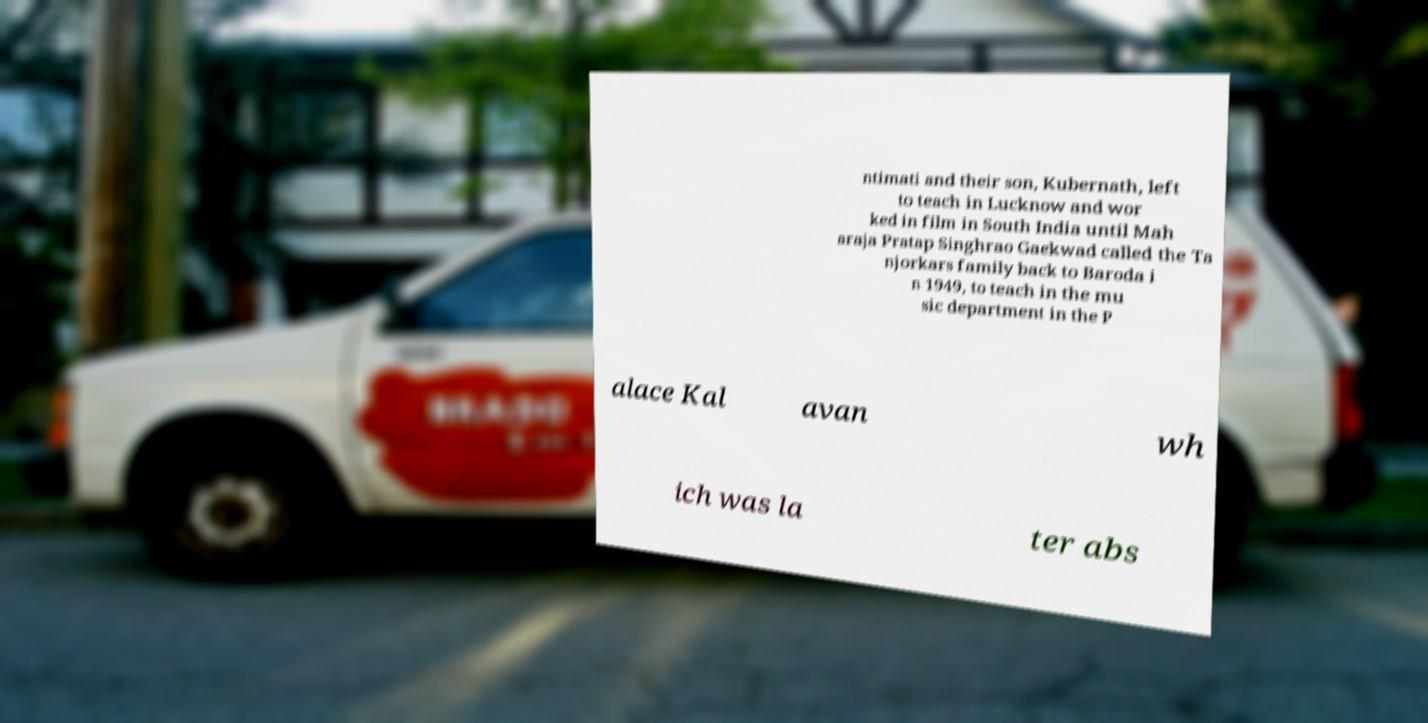Can you read and provide the text displayed in the image?This photo seems to have some interesting text. Can you extract and type it out for me? ntimati and their son, Kubernath, left to teach in Lucknow and wor ked in film in South India until Mah araja Pratap Singhrao Gaekwad called the Ta njorkars family back to Baroda i n 1949, to teach in the mu sic department in the P alace Kal avan wh ich was la ter abs 